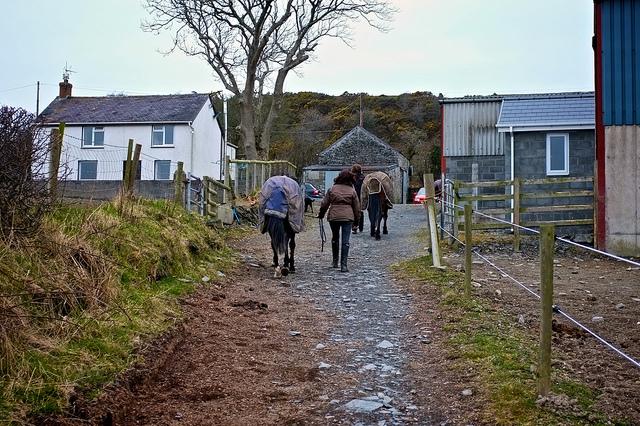What are the people carrying?
Give a very brief answer. Leashes. What vehicle did the people use to come to the event?
Answer briefly. Car. Is it spring?
Concise answer only. No. Are there leaves on the tree?
Short answer required. No. How many buildings are visible?
Keep it brief. 5. What is the dirt made of?
Answer briefly. Dirt. Is it raining?
Answer briefly. No. 